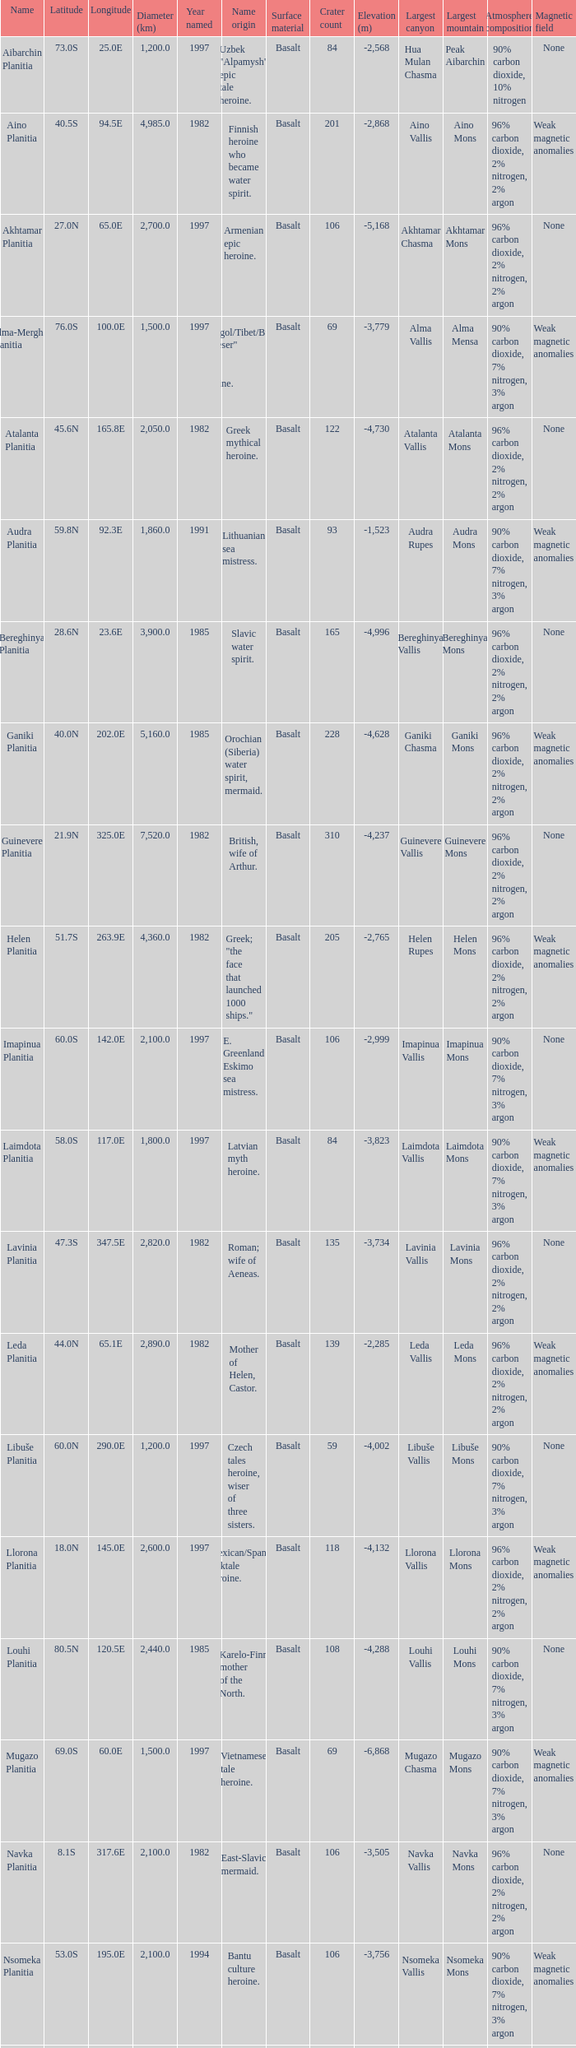What is the diameter (km) of longitude 170.1e 3655.0. 